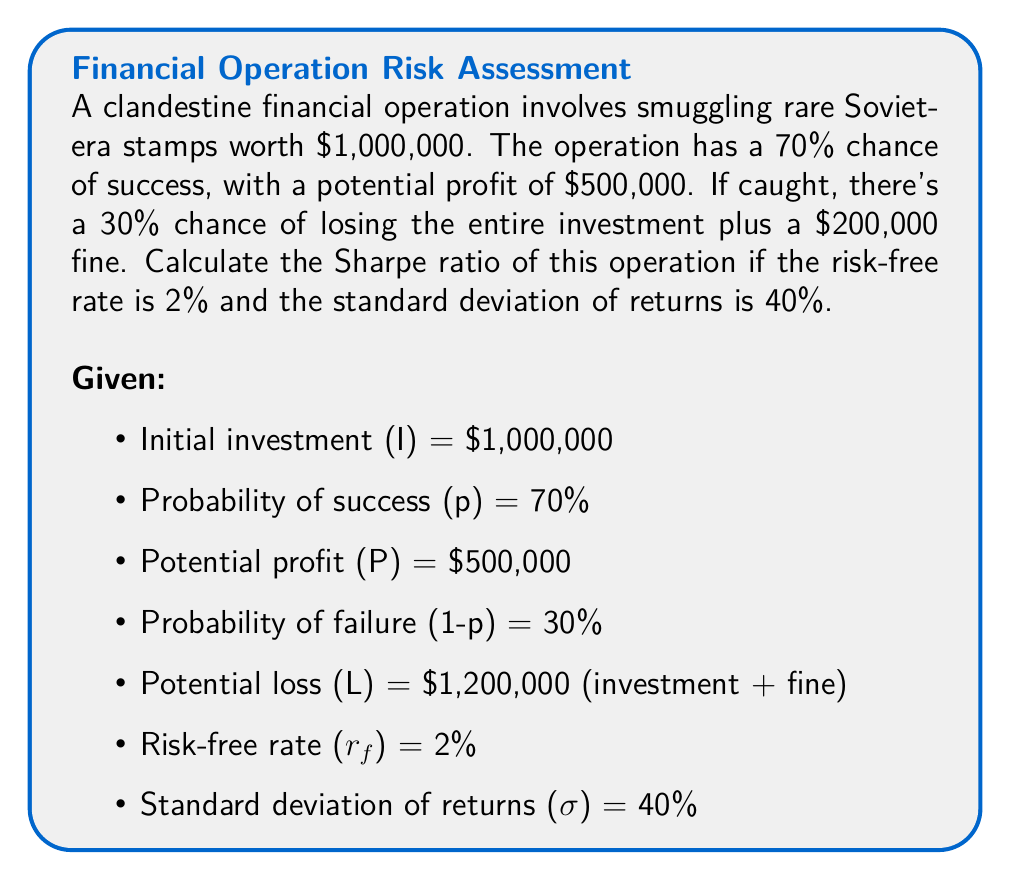What is the answer to this math problem? To calculate the Sharpe ratio, we need to follow these steps:

1. Calculate the expected return (E[R]):
   $$E[R] = p \cdot \frac{P}{I} + (1-p) \cdot (-\frac{L}{I})$$
   $$E[R] = 0.7 \cdot \frac{500,000}{1,000,000} + 0.3 \cdot (-\frac{1,200,000}{1,000,000})$$
   $$E[R] = 0.35 - 0.36 = -0.01 = -1\%$$

2. Convert the risk-free rate to a decimal:
   $$r_f = 0.02 = 2\%$$

3. Calculate the excess return:
   $$\text{Excess Return} = E[R] - r_f = -0.01 - 0.02 = -0.03 = -3\%$$

4. Convert the standard deviation to a decimal:
   $$σ = 0.40 = 40\%$$

5. Apply the Sharpe ratio formula:
   $$\text{Sharpe Ratio} = \frac{E[R] - r_f}{σ} = \frac{-0.03}{0.40} = -0.075$$

The negative Sharpe ratio indicates that the operation is expected to underperform the risk-free rate, suggesting it's not a favorable investment from a risk-adjusted return perspective.
Answer: -0.075 